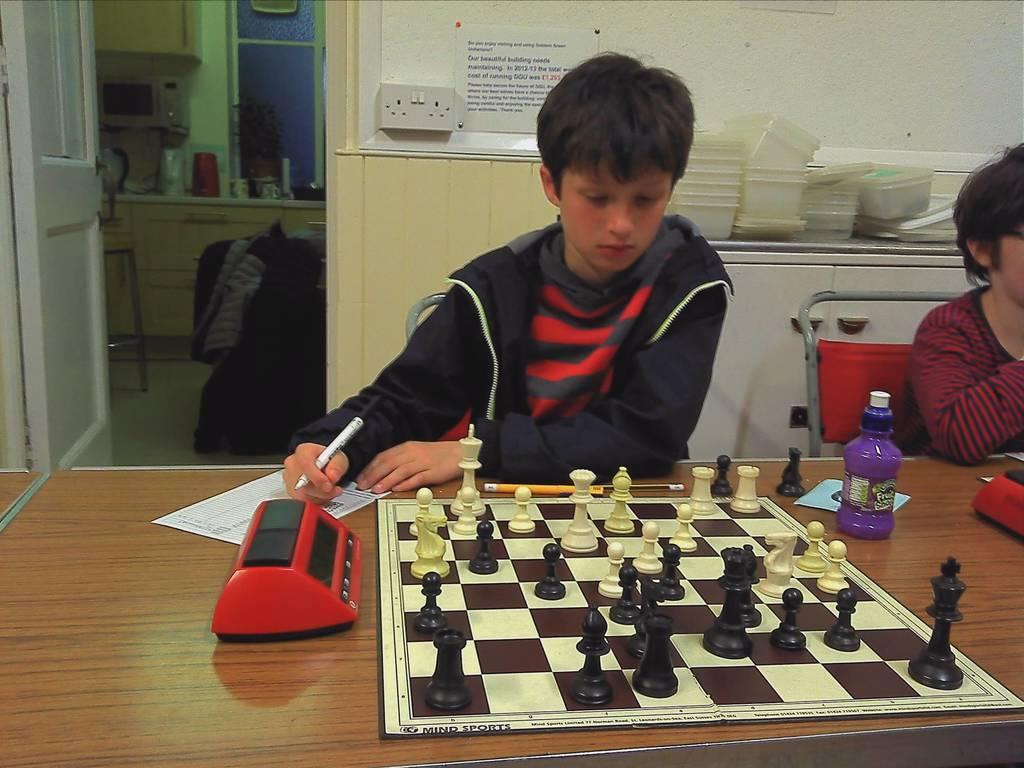Please provide a concise description of this image. on a table there is a chess board, water bottle, paper, pencils. In its front 2 people are sitting on red chairs. The person at the left is wearing a black coat and holding a pen in his hand. Right to him a person is sitting wearing a red and black t shirt. Behind them there is a white cupboard on which there are white box. Behind that there is a white wall. At the left there is a white door. At the there is another room in which there are cupboards, windows and other objects. 